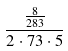Convert formula to latex. <formula><loc_0><loc_0><loc_500><loc_500>\frac { \frac { 8 } { 2 8 3 } } { 2 \cdot 7 3 \cdot 5 }</formula> 